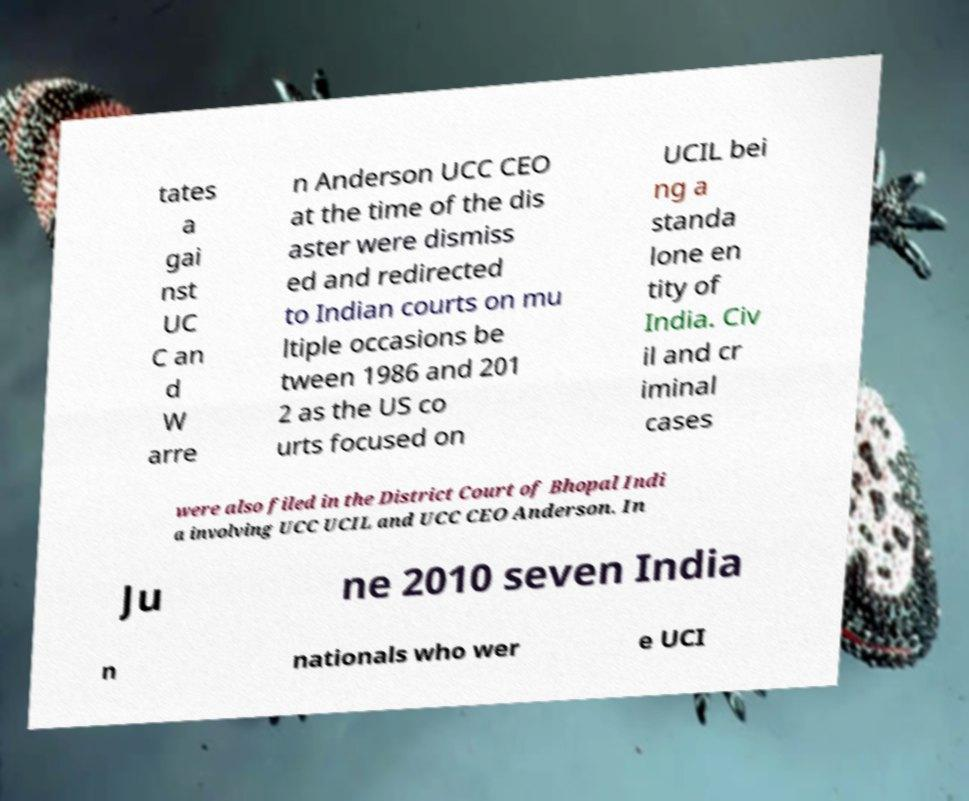Please identify and transcribe the text found in this image. tates a gai nst UC C an d W arre n Anderson UCC CEO at the time of the dis aster were dismiss ed and redirected to Indian courts on mu ltiple occasions be tween 1986 and 201 2 as the US co urts focused on UCIL bei ng a standa lone en tity of India. Civ il and cr iminal cases were also filed in the District Court of Bhopal Indi a involving UCC UCIL and UCC CEO Anderson. In Ju ne 2010 seven India n nationals who wer e UCI 